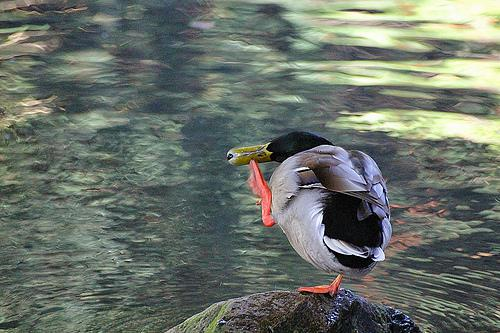Question: how is the rock?
Choices:
A. Dry.
B. Wet.
C. Soft.
D. Hard.
Answer with the letter. Answer: B Question: what bird is seen in the picture?
Choices:
A. Woodpecker.
B. Penguin.
C. Eagle.
D. Duck.
Answer with the letter. Answer: D Question: where is the duck standing?
Choices:
A. On the grass.
B. In the water.
C. In the rock.
D. In the mud.
Answer with the letter. Answer: C Question: how many ducks are seen?
Choices:
A. 2.
B. 4.
C. 10.
D. 1.
Answer with the letter. Answer: D 